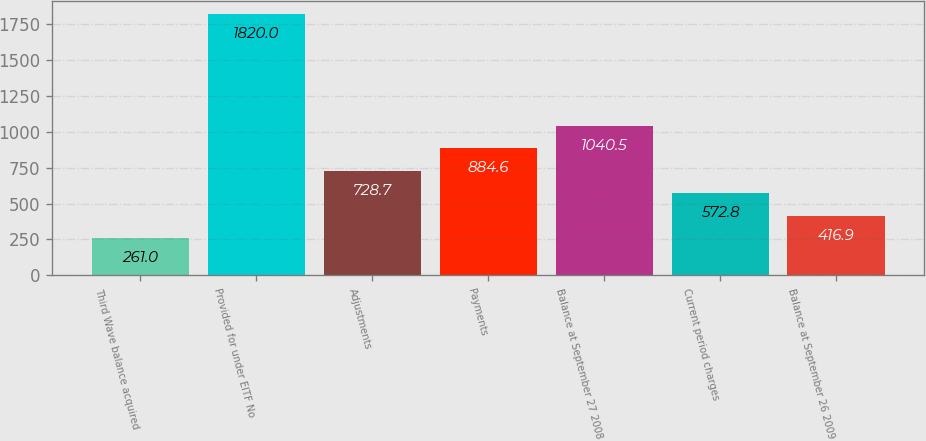Convert chart to OTSL. <chart><loc_0><loc_0><loc_500><loc_500><bar_chart><fcel>Third Wave balance acquired<fcel>Provided for under EITF No<fcel>Adjustments<fcel>Payments<fcel>Balance at September 27 2008<fcel>Current period charges<fcel>Balance at September 26 2009<nl><fcel>261<fcel>1820<fcel>728.7<fcel>884.6<fcel>1040.5<fcel>572.8<fcel>416.9<nl></chart> 